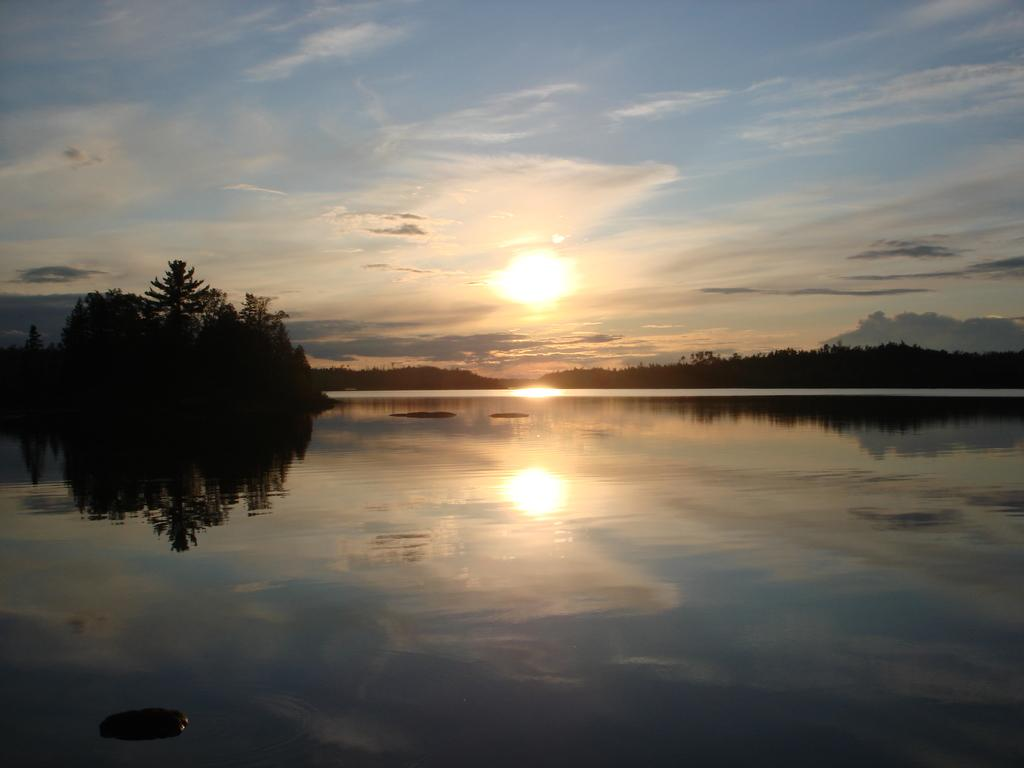What is the primary element visible in the image? There is water in the image. What can be seen in the background of the image? There are trees and the sky visible in the background of the image. Is the sun visible in the image? Yes, the sun is visible in the background of the image. What type of jeans is the minister wearing in the image? There is no minister or jeans present in the image. 